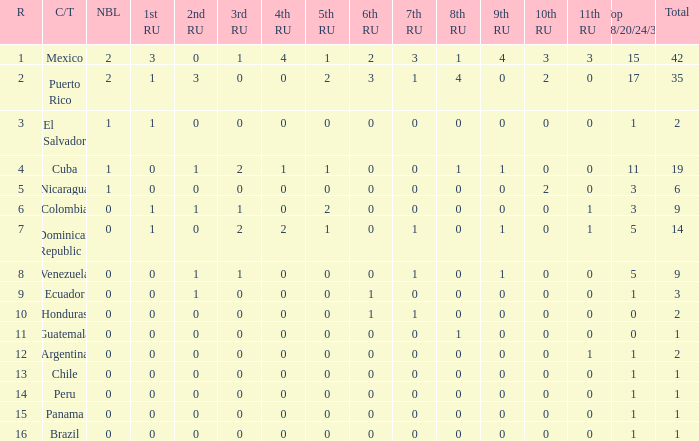What is the 7th runner-up of the country with a 10th runner-up greater than 0, a 9th runner-up greater than 0, and an 8th runner-up greater than 1? None. 